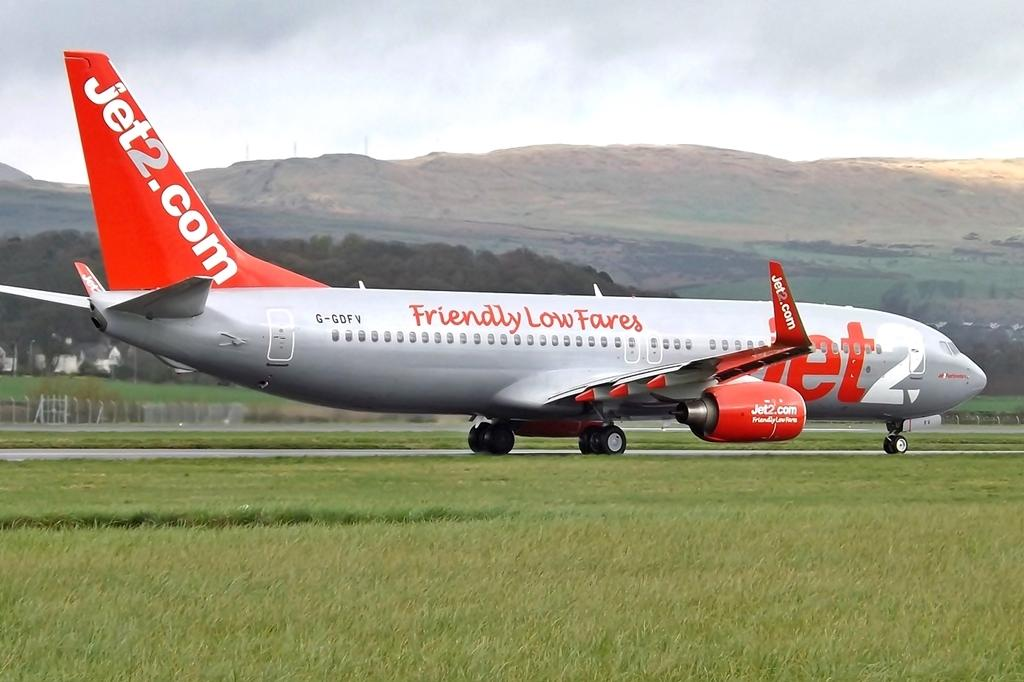<image>
Summarize the visual content of the image. the plane says friendly low fares is a Jet airlines plane 